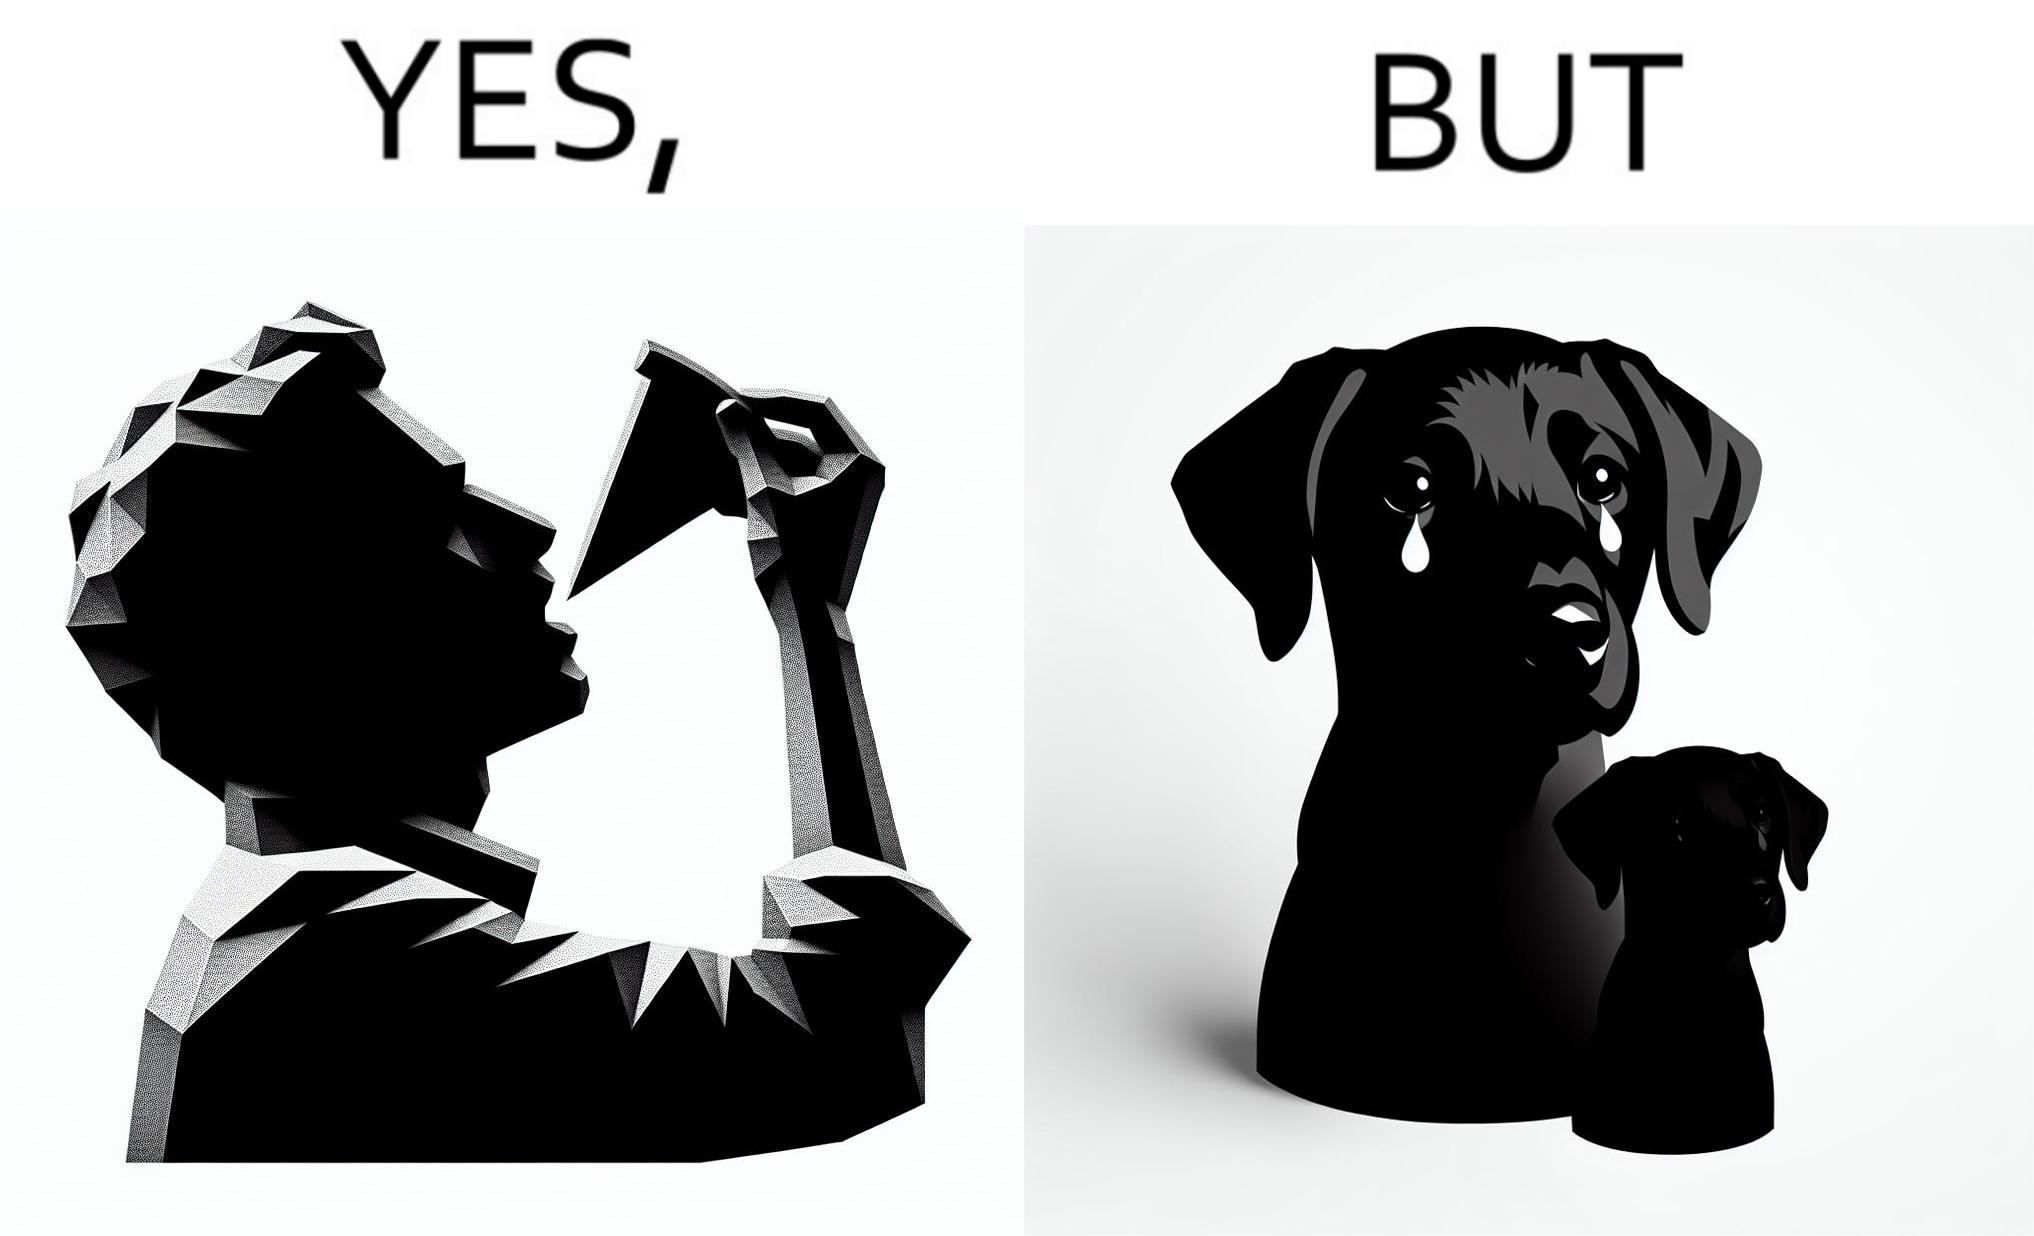Provide a description of this image. The images are funny since they show how pet owners cannot enjoy any tasty food like pizza without sharing with their pets. The look from the pets makes the owner too guilty if he does not share his food 